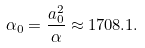Convert formula to latex. <formula><loc_0><loc_0><loc_500><loc_500>\alpha _ { 0 } = \frac { a _ { 0 } ^ { 2 } } { \alpha } \approx 1 7 0 8 . 1 .</formula> 